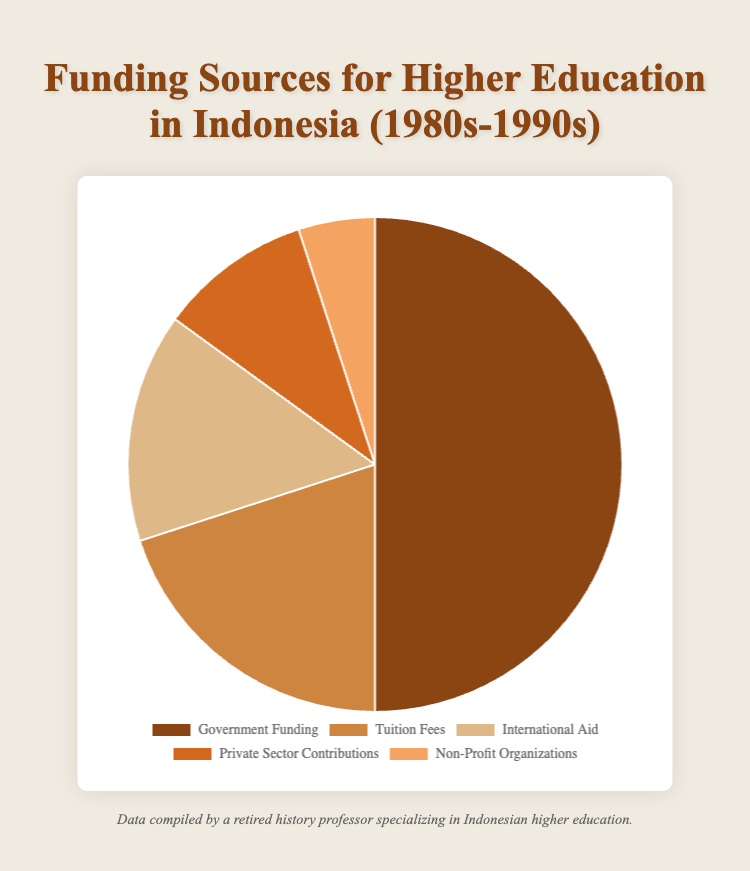What's the most significant funding source for higher education in Indonesia during the 1980s-1990s? Identify the largest slice in the pie chart, which represents Government Funding.
Answer: Government Funding Which two funding sources contribute a total of 25% together? Look for the funding sources whose percentages add up to 25%. Private Sector Contributions (10%) and Non-Profit Organizations (5%) together make 15%, so it's International Aid (15%) and Non-Profit Organizations (5%) that make 20%.
Answer: International Aid and Non-Profit Organizations What is the difference in percentage between Government Funding and Tuition Fees? Subtract the percentage of Tuition Fees from the percentage of Government Funding, which is 50% - 20%.
Answer: 30% Which funding source has the smallest contribution to higher education funding? Identify the smallest slice in the pie chart, which represents Non-Profit Organizations.
Answer: Non-Profit Organizations What is the average percentage contribution of the three funding sources with the smallest percentages? Add the percentages of the three smallest funding sources and divide by three: (15% + 10% + 5%) / 3.
Answer: 10% Is the total contribution of International Aid and Tuition Fees greater than that of Government Funding? Add the percentages of International Aid and Tuition Fees: 15% + 20% = 35%, which is less than Government Funding (50%).
Answer: No Which funding source occupies the second largest share in the pie chart? Identify the second largest slice in the pie chart, which represents Tuition Fees.
Answer: Tuition Fees What percentage difference exists between the contributions of Private Sector Contributions and Non-Profit Organizations? Subtract the percentage of Non-Profit Organizations from Private Sector Contributions: 10% - 5%.
Answer: 5% Which funding sources together contribute 30% of the funding? Sum the percentages of the three smallest slices: International Aid (15%), Private Sector Contributions (10%), and Non-Profit Organizations (5%), which together make 30%.
Answer: International Aid, Private Sector Contributions, and Non-Profit Organizations 